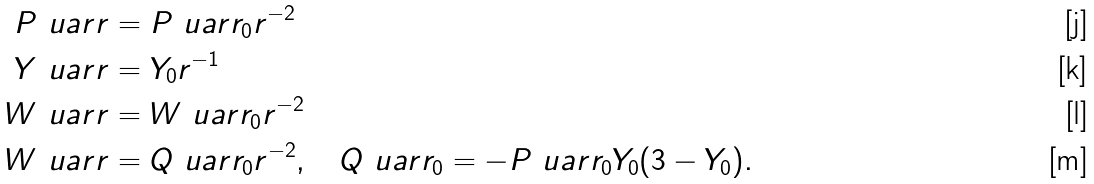Convert formula to latex. <formula><loc_0><loc_0><loc_500><loc_500>P ^ { \ } u a r r & = P ^ { \ } u a r r _ { 0 } r ^ { - 2 } \\ Y ^ { \ } u a r r & = Y _ { 0 } r ^ { - 1 } \\ W ^ { \ } u a r r & = W ^ { \ } u a r r _ { 0 } r ^ { - 2 } \\ W ^ { \ } u a r r & = Q ^ { \ } u a r r _ { 0 } r ^ { - 2 } , \quad Q ^ { \ } u a r r _ { 0 } = - P ^ { \ } u a r r _ { 0 } Y _ { 0 } ( 3 - Y _ { 0 } ) .</formula> 